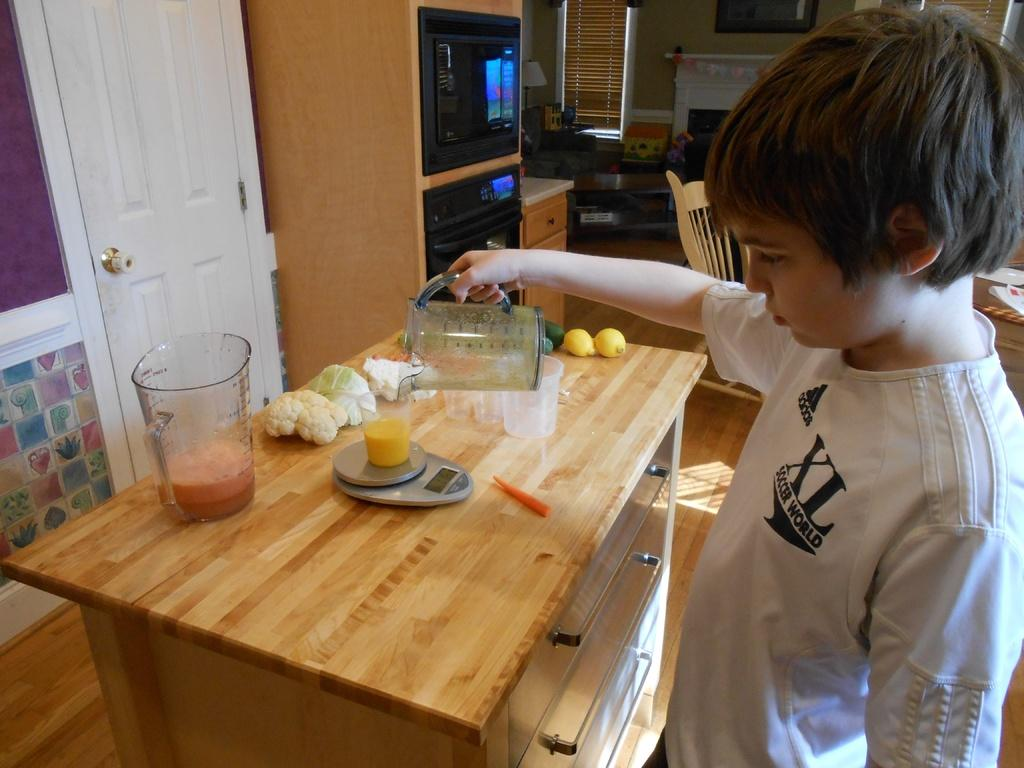<image>
Provide a brief description of the given image. A child is pouring a drink and measuring it while wearing a shirt with an adidas XL Soccer World logo. 